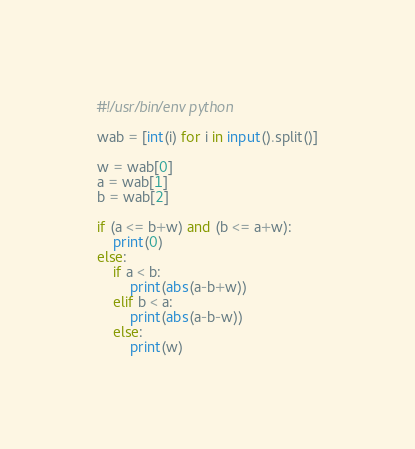Convert code to text. <code><loc_0><loc_0><loc_500><loc_500><_Python_>#!/usr/bin/env python

wab = [int(i) for i in input().split()]

w = wab[0]
a = wab[1]
b = wab[2]

if (a <= b+w) and (b <= a+w):
    print(0)
else:
    if a < b:
        print(abs(a-b+w))
    elif b < a:
        print(abs(a-b-w))
    else:
        print(w)</code> 